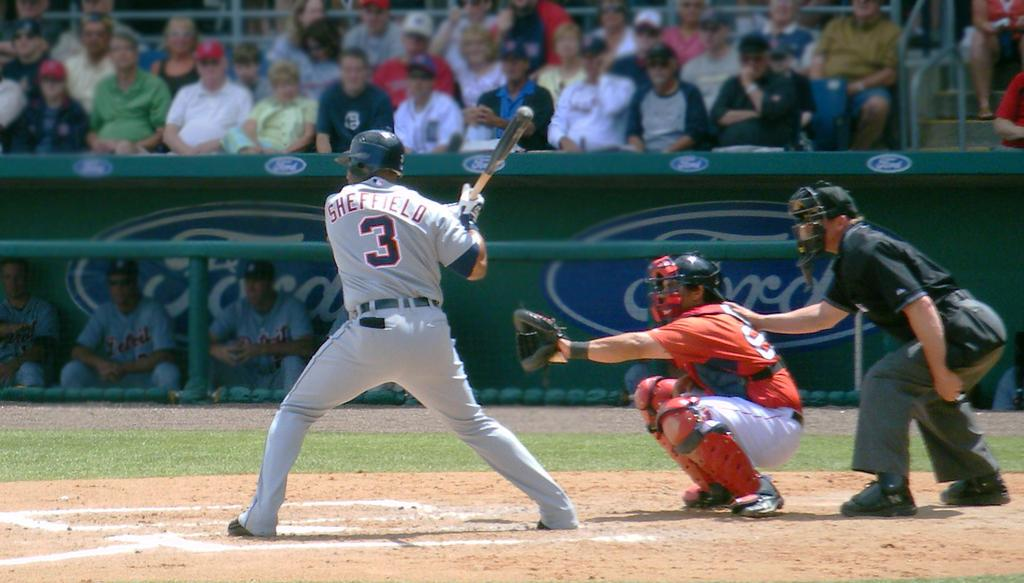<image>
Render a clear and concise summary of the photo. A man in a baseball uniform that says Sheffield on the back gets ready to swing his bat. 